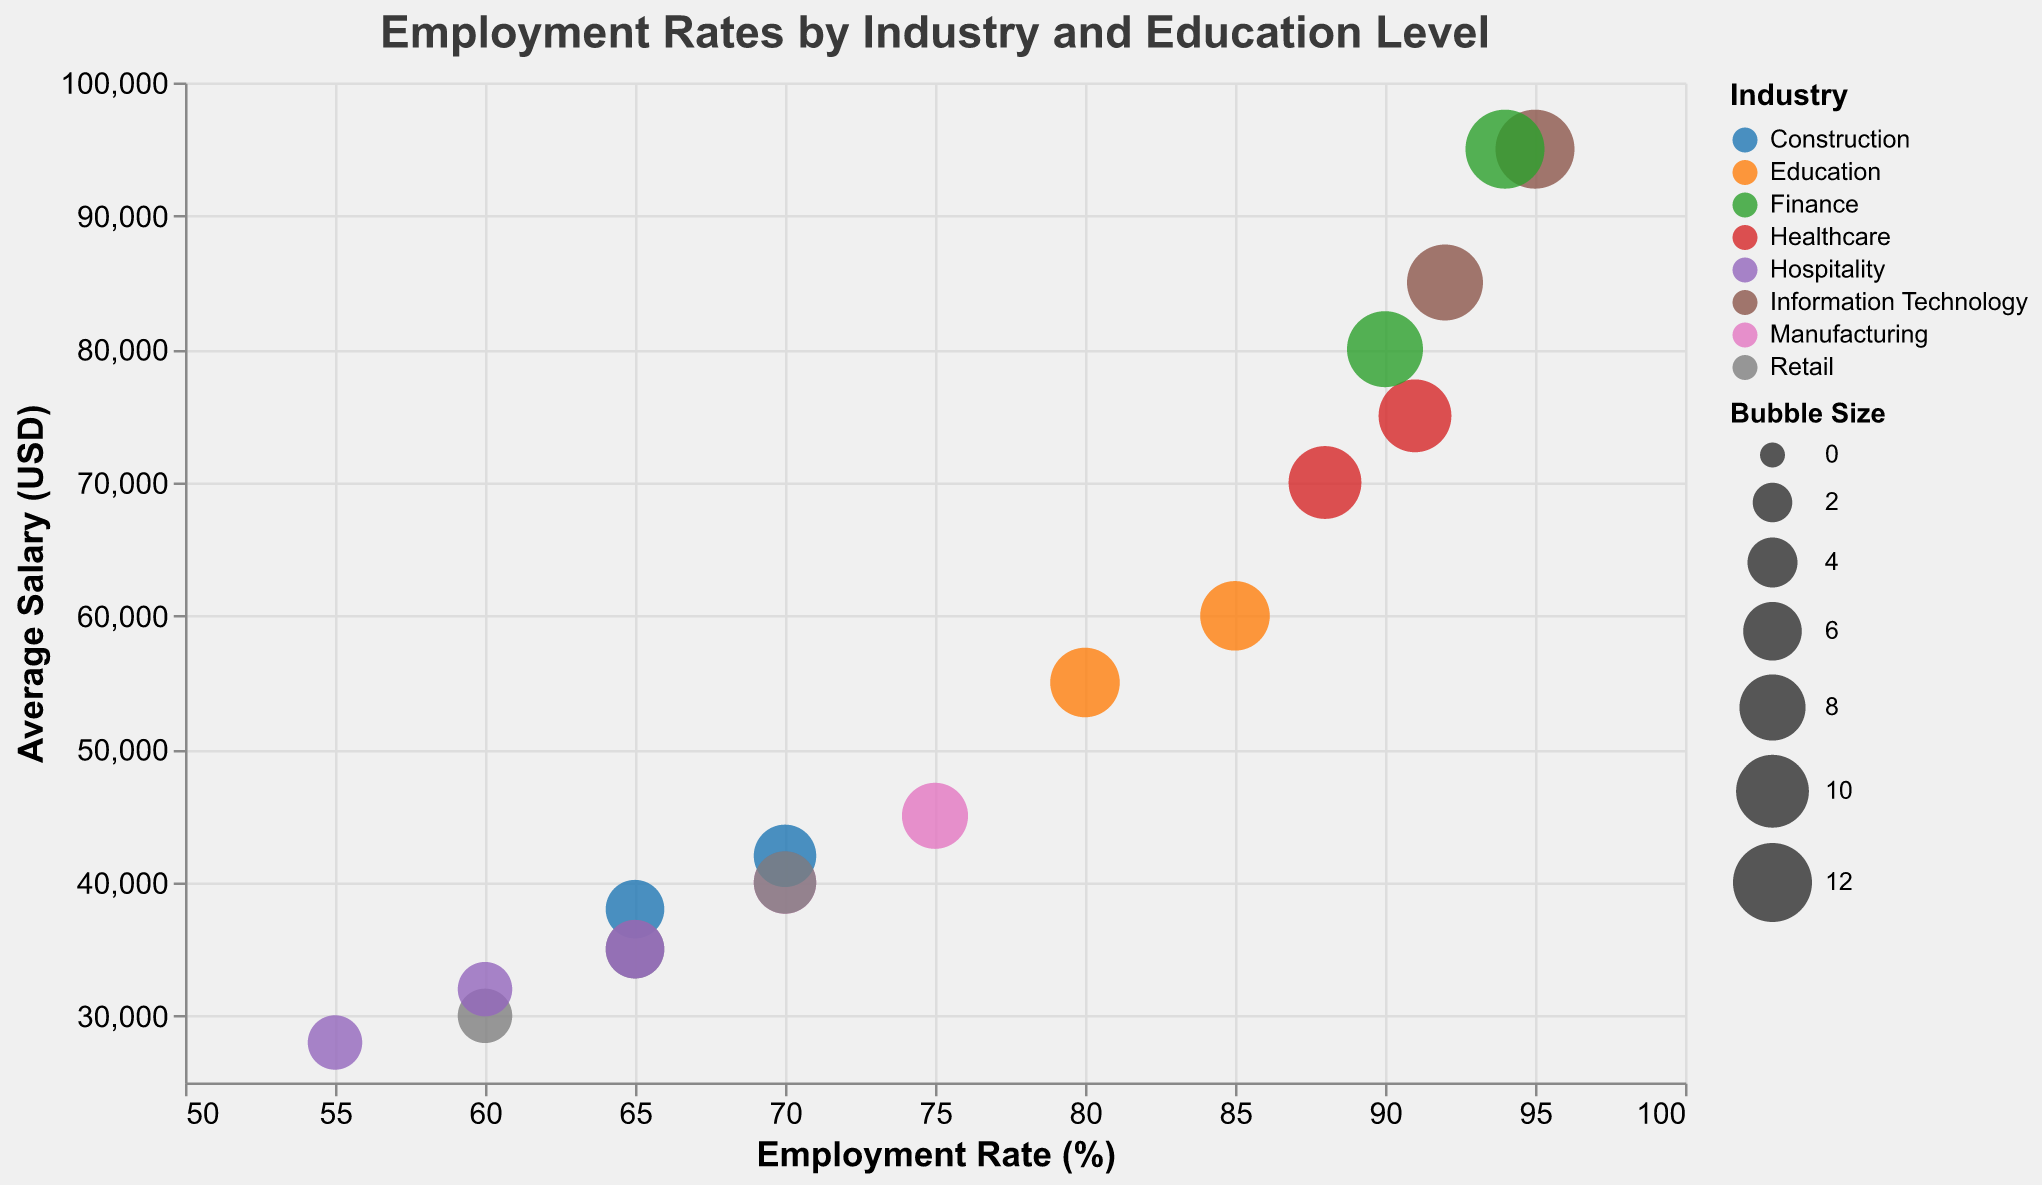What is the highest employment rate depicted in the chart? To find the highest employment rate, look at the x-axis where "Employment Rate (%)" is marked and identify the data point furthest to the right.
Answer: 95% Which industry has the lowest average salary for Bachelor's Degree holders? To find this, look at the y-axis where "Average Salary (USD)" is marked and identify the Bachelor's Degree data points. Compare the salary values; the lowest point should be the highest data point with the smallest y-value.
Answer: Education How does the employment rate for Master's Degree holders in Finance compare to those in Information Technology? Compare the horizontal positions (employment rates) of the bubbles representing Master's Degree holders in Finance and Information Technology. Locate the bubbles and compare their positions on the x-axis.
Answer: Finance has a slightly lower employment rate (94% vs 95%) Which industry shows the most significant increase in average salary when comparing Bachelor's Degree holders to Master's Degree holders? Compare the vertical distances (average salary) between Bachelor's Degree and Master's Degree bubbles within the same industry. Look for the industry where this difference is largest.
Answer: Information Technology What is the overall trend in employment rates as education level increases across different industries? Observe the patterns in the x-axis positions of the bubbles within each industry. Analyze how the employment rates change as you move from High School Diploma to Bachelor's Degree and then to Master's Degree.
Answer: Employment rates generally increase Compare the bubble sizes for Information Technology and Healthcare at the Master's Degree level. What can you infer from these sizes? Look specifically at the bubble sizes for Information Technology and Healthcare, both for Master's Degree holders. Compare the areas of these bubbles which are encoded by the data field for bubble size.
Answer: Information Technology has a slightly larger bubble size, indicating relatively more data points or higher significance What is the employment rate and average salary for Bachelor's Degree holders in the Retail industry? Identify the bubble corresponding to Retail Bachelor's Degree holders and read off the values from both the x-axis (employment rate) and y-axis (average salary).
Answer: 70%, $40,000 Which industry has the highest employment rate for High School Diploma holders, and what is the corresponding salary? Locate the bubbles representing High School Diploma holders and find the one with the highest x-axis value (employment rate). Then read the corresponding y-axis value (average salary).
Answer: Manufacturing, $40,000 